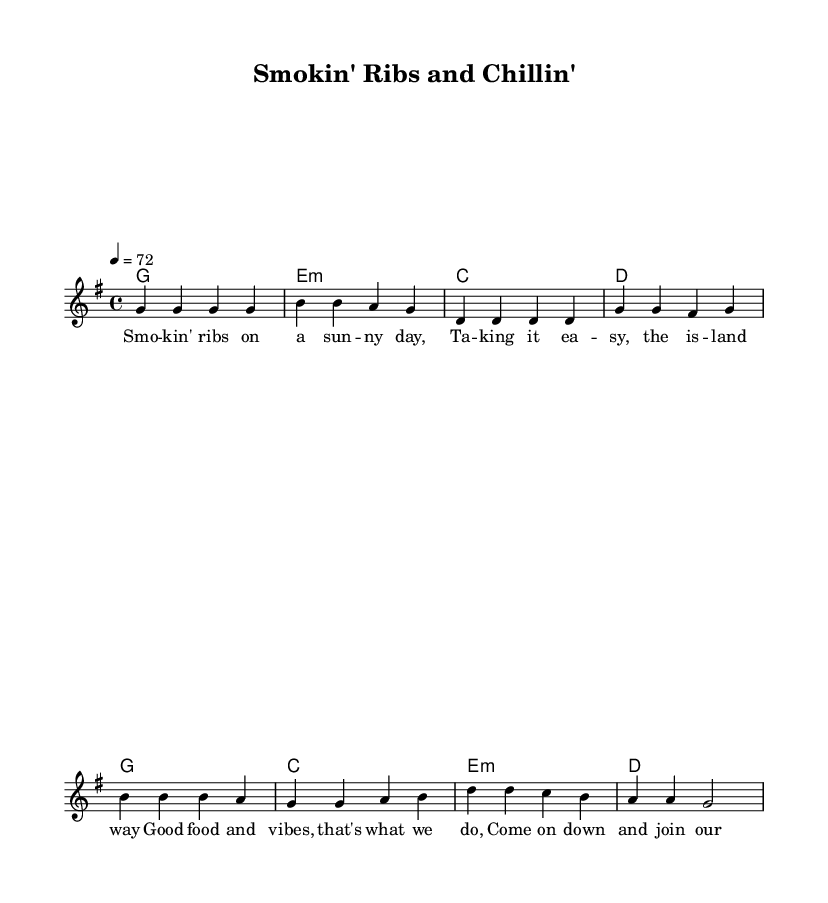What is the key signature of this music? The key signature is G major, which has one sharp (F#). You can identify this by looking at the key signature indicated at the beginning of the staff.
Answer: G major What is the time signature of the music? The time signature is 4/4, indicated at the start of the score. This means there are four beats in a measure, and a quarter note receives one beat.
Answer: 4/4 What is the tempo marking of this piece? The tempo marking is "4 = 72," which indicates that there should be 72 beats per minute, counted based on quarter notes.
Answer: 72 How many measures are in the verse? The verse consists of four measures, as indicated by the grouping of the notes and chords in that section of the score.
Answer: 4 Which chords are used in the chorus section? The chords in the chorus are G, C, E minor, and D. You can identify these by looking at the chord symbols above the corresponding measures in the chorus.
Answer: G, C, E minor, D What is the main theme of the lyrics? The main theme revolves around enjoying good food and relaxed vibes, as reflected in the lyrics describing a sunny day and coming together to enjoy the experience.
Answer: Good food and vibes 